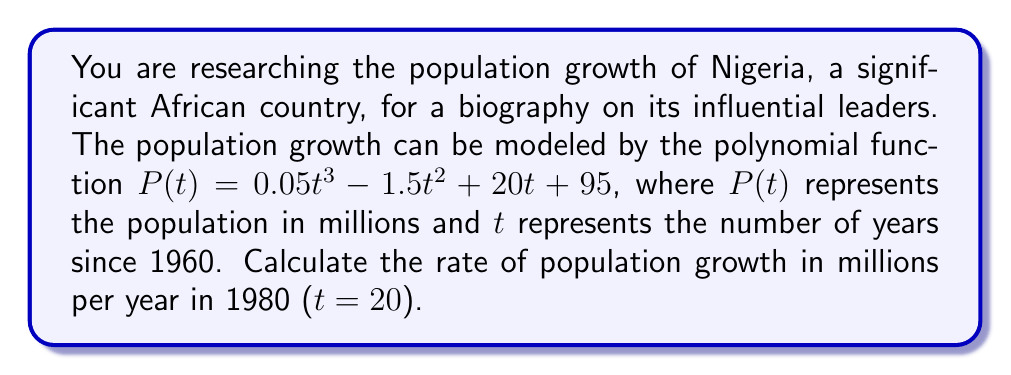Can you solve this math problem? To find the rate of population growth at a specific point in time, we need to calculate the derivative of the population function and evaluate it at the given time.

Step 1: Find the derivative of $P(t)$.
$P'(t) = \frac{d}{dt}(0.05t^3 - 1.5t^2 + 20t + 95)$
$P'(t) = 0.15t^2 - 3t + 20$

Step 2: Evaluate $P'(t)$ at $t = 20$ (representing 1980).
$P'(20) = 0.15(20)^2 - 3(20) + 20$
$P'(20) = 0.15(400) - 60 + 20$
$P'(20) = 60 - 60 + 20$
$P'(20) = 20$

The rate of population growth in 1980 is 20 million people per year.
Answer: 20 million per year 